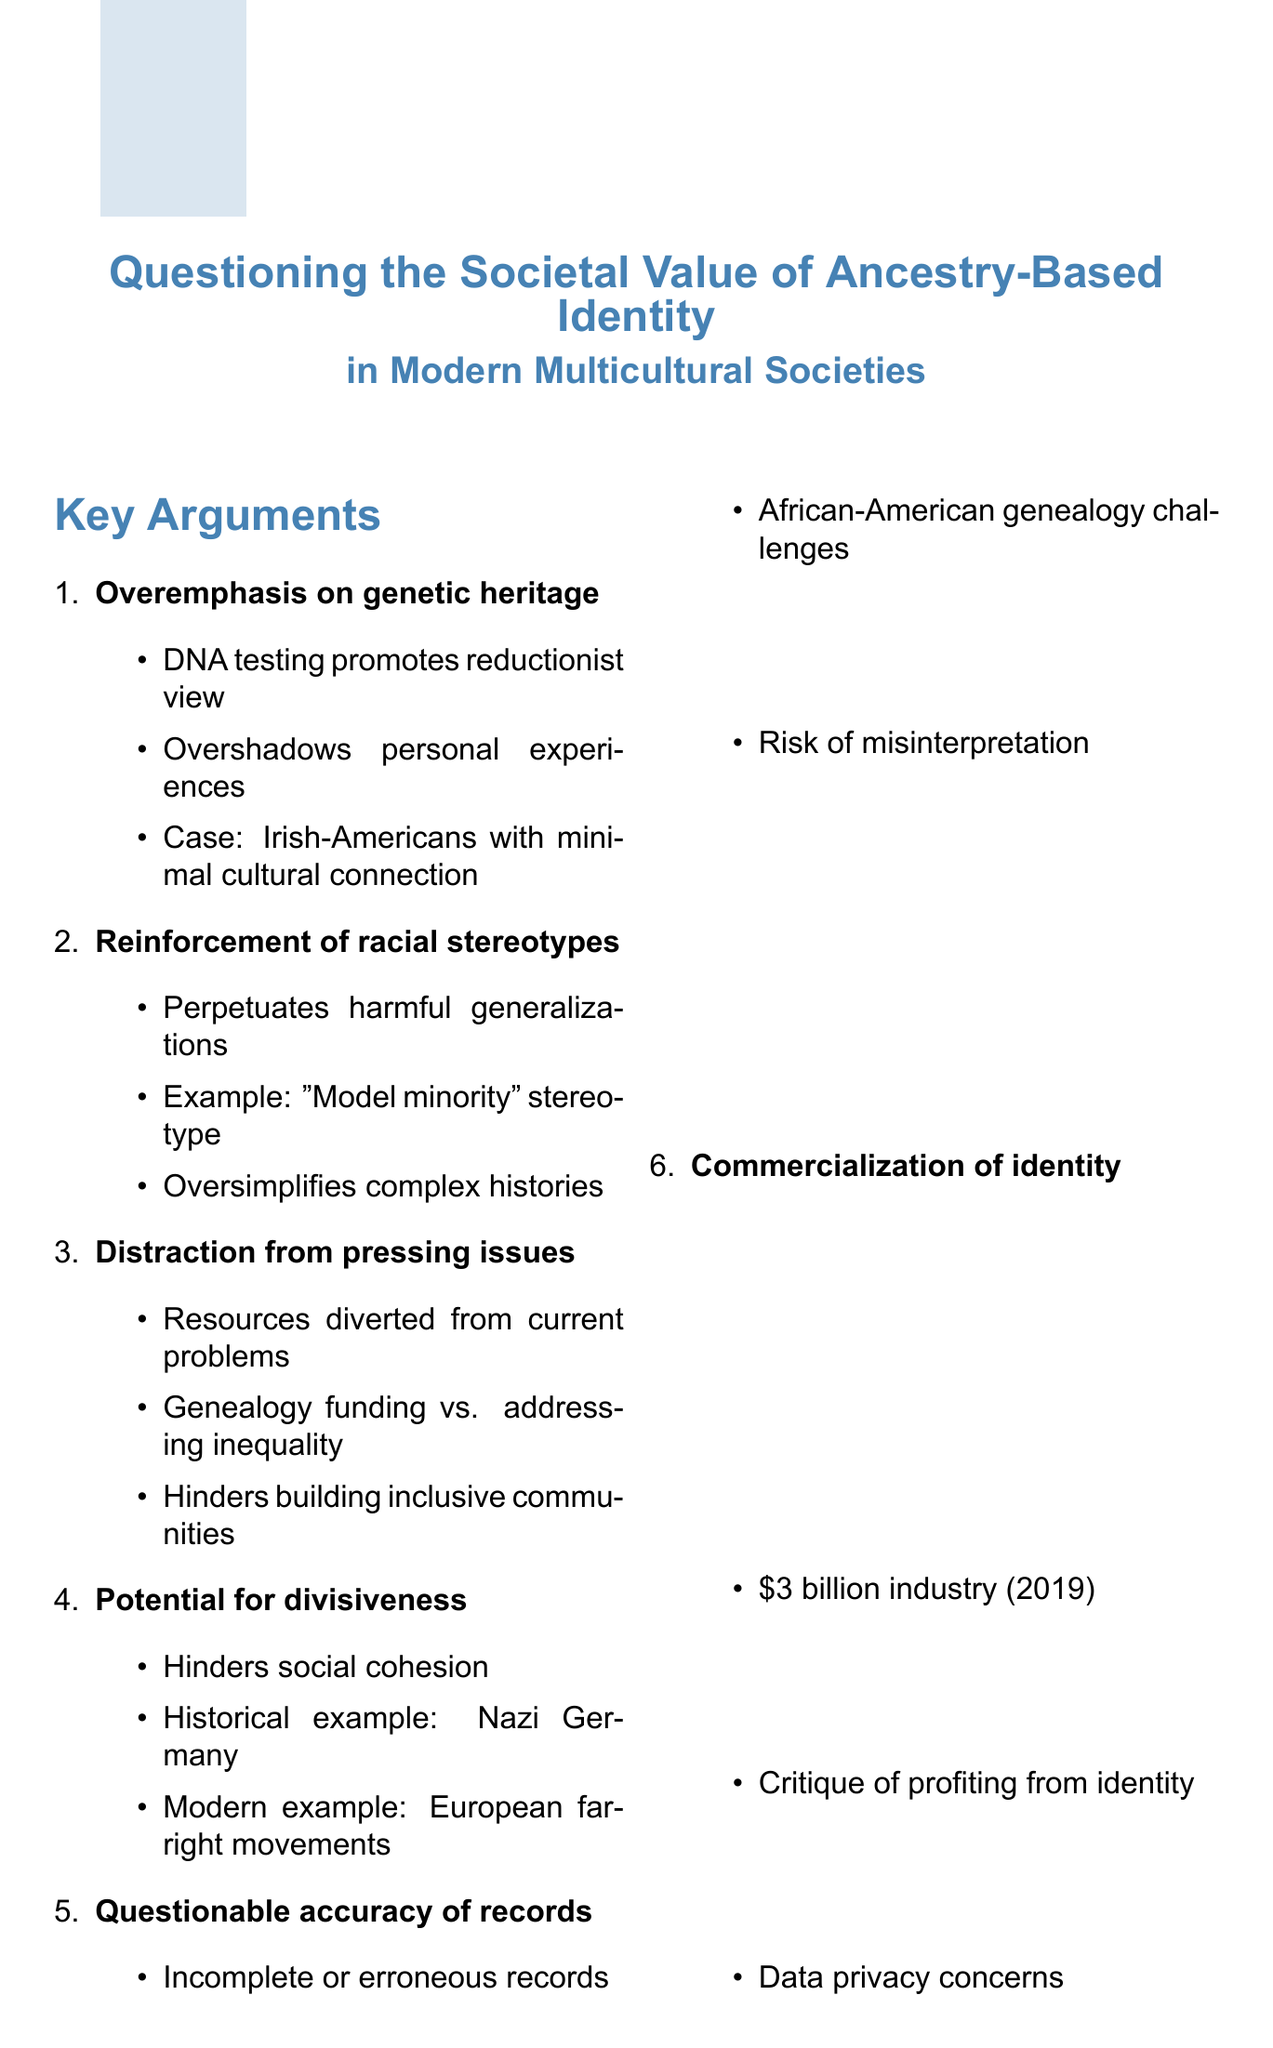what is the memo title? The title of the memo encapsulates the main theme of questioning ancestry-based identity.
Answer: Questioning the Societal Value of Ancestry-Based Identity in Modern Multicultural Societies how many key arguments are listed in the memo? The total number of key arguments is specified in the document.
Answer: six who is the President of the Social Science Research Council mentioned in the document? The document cites Dr. Alondra Nelson as the President of the Social Science Research Council.
Answer: Dr. Alondra Nelson what industry valuation is mentioned for the ancestry research industry in 2019? The specific monetary value of the ancestry research industry is provided for the year 2019.
Answer: over $3 billion which argument suggests a connection between ancestry and societal division? This argument relates to the impact of ancestry on social cohesion and cites historical examples.
Answer: Potential for divisiveness what does the conclusion of the memo suggest about ancestry-based identity? The conclusion provides a critical perspective on the societal role of ancestry-based identity.
Answer: potentially harmful who provides a viewpoint stating ancestry identities reflect a retreat from civic belonging? The memo includes an opinion from an expert regarding ancestry identities and civic belonging.
Answer: Professor Rogers Brubaker what is one of the counter-arguments listed in the document? The document includes counter-arguments that support the value of ancestry research.
Answer: Preserves cultural heritage 